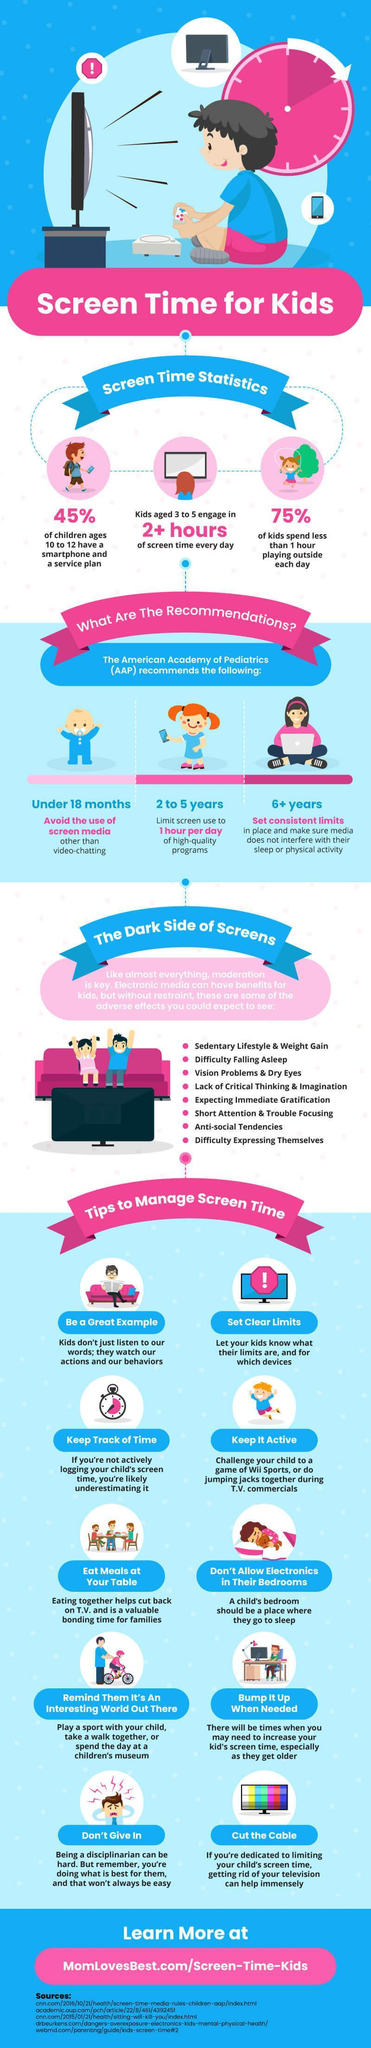What is the recommended screen time by AAP for 2 to 5 year kids?
Answer the question with a short phrase. 1 hour per day How many of the kids between 10 & 12 use smartphones? 45% Kids in which age group are engaged in more than 2 hours of screen time daily? 3 to 5 What percent of kids are spending lesser time outdoors? 75% What is listed sixth among the side effects of excess screen time? Short attention & trouble focusing For which age group should use of screen media be avoided? under 18 months What is listed second as the side effects of excess screen time? Difficulty falling asleep 